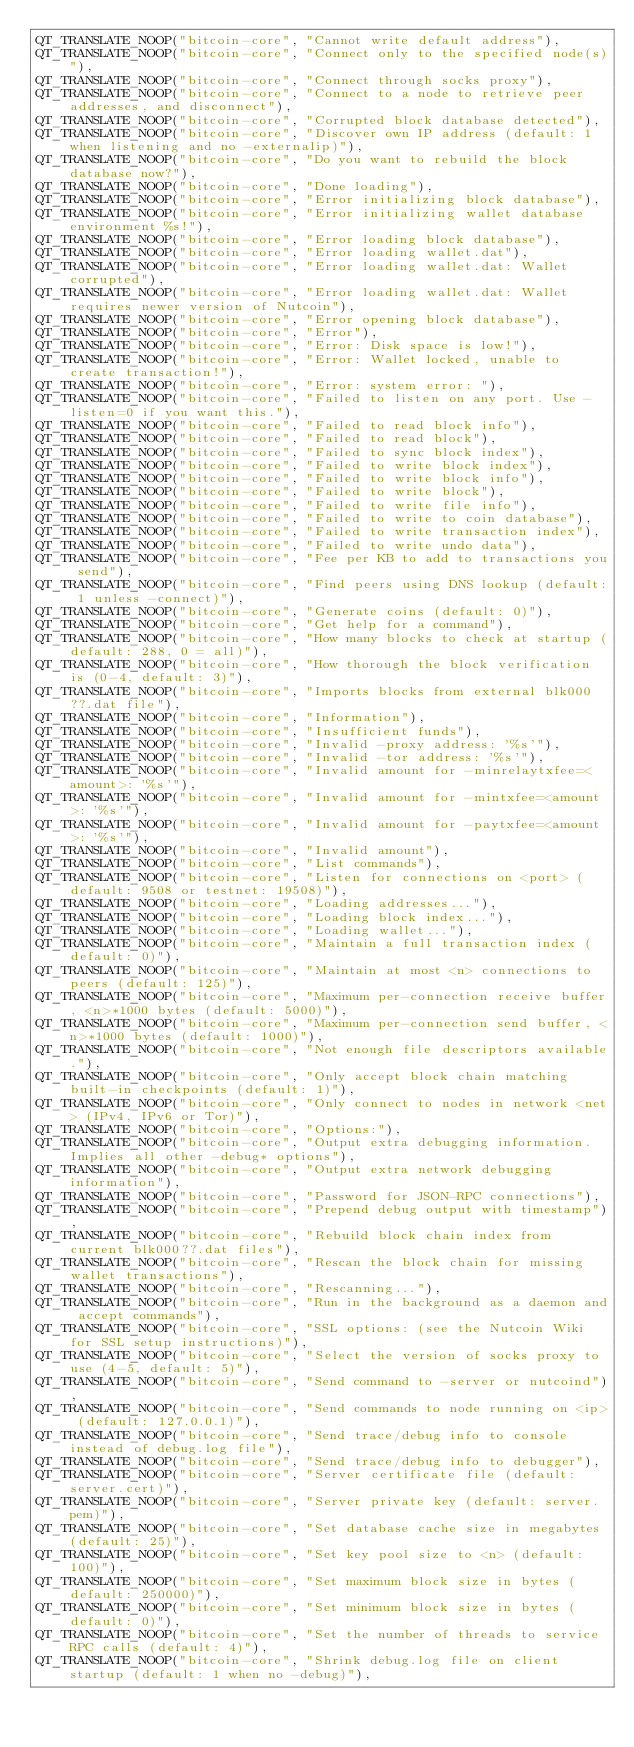Convert code to text. <code><loc_0><loc_0><loc_500><loc_500><_C++_>QT_TRANSLATE_NOOP("bitcoin-core", "Cannot write default address"),
QT_TRANSLATE_NOOP("bitcoin-core", "Connect only to the specified node(s)"),
QT_TRANSLATE_NOOP("bitcoin-core", "Connect through socks proxy"),
QT_TRANSLATE_NOOP("bitcoin-core", "Connect to a node to retrieve peer addresses, and disconnect"),
QT_TRANSLATE_NOOP("bitcoin-core", "Corrupted block database detected"),
QT_TRANSLATE_NOOP("bitcoin-core", "Discover own IP address (default: 1 when listening and no -externalip)"),
QT_TRANSLATE_NOOP("bitcoin-core", "Do you want to rebuild the block database now?"),
QT_TRANSLATE_NOOP("bitcoin-core", "Done loading"),
QT_TRANSLATE_NOOP("bitcoin-core", "Error initializing block database"),
QT_TRANSLATE_NOOP("bitcoin-core", "Error initializing wallet database environment %s!"),
QT_TRANSLATE_NOOP("bitcoin-core", "Error loading block database"),
QT_TRANSLATE_NOOP("bitcoin-core", "Error loading wallet.dat"),
QT_TRANSLATE_NOOP("bitcoin-core", "Error loading wallet.dat: Wallet corrupted"),
QT_TRANSLATE_NOOP("bitcoin-core", "Error loading wallet.dat: Wallet requires newer version of Nutcoin"),
QT_TRANSLATE_NOOP("bitcoin-core", "Error opening block database"),
QT_TRANSLATE_NOOP("bitcoin-core", "Error"),
QT_TRANSLATE_NOOP("bitcoin-core", "Error: Disk space is low!"),
QT_TRANSLATE_NOOP("bitcoin-core", "Error: Wallet locked, unable to create transaction!"),
QT_TRANSLATE_NOOP("bitcoin-core", "Error: system error: "),
QT_TRANSLATE_NOOP("bitcoin-core", "Failed to listen on any port. Use -listen=0 if you want this."),
QT_TRANSLATE_NOOP("bitcoin-core", "Failed to read block info"),
QT_TRANSLATE_NOOP("bitcoin-core", "Failed to read block"),
QT_TRANSLATE_NOOP("bitcoin-core", "Failed to sync block index"),
QT_TRANSLATE_NOOP("bitcoin-core", "Failed to write block index"),
QT_TRANSLATE_NOOP("bitcoin-core", "Failed to write block info"),
QT_TRANSLATE_NOOP("bitcoin-core", "Failed to write block"),
QT_TRANSLATE_NOOP("bitcoin-core", "Failed to write file info"),
QT_TRANSLATE_NOOP("bitcoin-core", "Failed to write to coin database"),
QT_TRANSLATE_NOOP("bitcoin-core", "Failed to write transaction index"),
QT_TRANSLATE_NOOP("bitcoin-core", "Failed to write undo data"),
QT_TRANSLATE_NOOP("bitcoin-core", "Fee per KB to add to transactions you send"),
QT_TRANSLATE_NOOP("bitcoin-core", "Find peers using DNS lookup (default: 1 unless -connect)"),
QT_TRANSLATE_NOOP("bitcoin-core", "Generate coins (default: 0)"),
QT_TRANSLATE_NOOP("bitcoin-core", "Get help for a command"),
QT_TRANSLATE_NOOP("bitcoin-core", "How many blocks to check at startup (default: 288, 0 = all)"),
QT_TRANSLATE_NOOP("bitcoin-core", "How thorough the block verification is (0-4, default: 3)"),
QT_TRANSLATE_NOOP("bitcoin-core", "Imports blocks from external blk000??.dat file"),
QT_TRANSLATE_NOOP("bitcoin-core", "Information"),
QT_TRANSLATE_NOOP("bitcoin-core", "Insufficient funds"),
QT_TRANSLATE_NOOP("bitcoin-core", "Invalid -proxy address: '%s'"),
QT_TRANSLATE_NOOP("bitcoin-core", "Invalid -tor address: '%s'"),
QT_TRANSLATE_NOOP("bitcoin-core", "Invalid amount for -minrelaytxfee=<amount>: '%s'"),
QT_TRANSLATE_NOOP("bitcoin-core", "Invalid amount for -mintxfee=<amount>: '%s'"),
QT_TRANSLATE_NOOP("bitcoin-core", "Invalid amount for -paytxfee=<amount>: '%s'"),
QT_TRANSLATE_NOOP("bitcoin-core", "Invalid amount"),
QT_TRANSLATE_NOOP("bitcoin-core", "List commands"),
QT_TRANSLATE_NOOP("bitcoin-core", "Listen for connections on <port> (default: 9508 or testnet: 19508)"),
QT_TRANSLATE_NOOP("bitcoin-core", "Loading addresses..."),
QT_TRANSLATE_NOOP("bitcoin-core", "Loading block index..."),
QT_TRANSLATE_NOOP("bitcoin-core", "Loading wallet..."),
QT_TRANSLATE_NOOP("bitcoin-core", "Maintain a full transaction index (default: 0)"),
QT_TRANSLATE_NOOP("bitcoin-core", "Maintain at most <n> connections to peers (default: 125)"),
QT_TRANSLATE_NOOP("bitcoin-core", "Maximum per-connection receive buffer, <n>*1000 bytes (default: 5000)"),
QT_TRANSLATE_NOOP("bitcoin-core", "Maximum per-connection send buffer, <n>*1000 bytes (default: 1000)"),
QT_TRANSLATE_NOOP("bitcoin-core", "Not enough file descriptors available."),
QT_TRANSLATE_NOOP("bitcoin-core", "Only accept block chain matching built-in checkpoints (default: 1)"),
QT_TRANSLATE_NOOP("bitcoin-core", "Only connect to nodes in network <net> (IPv4, IPv6 or Tor)"),
QT_TRANSLATE_NOOP("bitcoin-core", "Options:"),
QT_TRANSLATE_NOOP("bitcoin-core", "Output extra debugging information. Implies all other -debug* options"),
QT_TRANSLATE_NOOP("bitcoin-core", "Output extra network debugging information"),
QT_TRANSLATE_NOOP("bitcoin-core", "Password for JSON-RPC connections"),
QT_TRANSLATE_NOOP("bitcoin-core", "Prepend debug output with timestamp"),
QT_TRANSLATE_NOOP("bitcoin-core", "Rebuild block chain index from current blk000??.dat files"),
QT_TRANSLATE_NOOP("bitcoin-core", "Rescan the block chain for missing wallet transactions"),
QT_TRANSLATE_NOOP("bitcoin-core", "Rescanning..."),
QT_TRANSLATE_NOOP("bitcoin-core", "Run in the background as a daemon and accept commands"),
QT_TRANSLATE_NOOP("bitcoin-core", "SSL options: (see the Nutcoin Wiki for SSL setup instructions)"),
QT_TRANSLATE_NOOP("bitcoin-core", "Select the version of socks proxy to use (4-5, default: 5)"),
QT_TRANSLATE_NOOP("bitcoin-core", "Send command to -server or nutcoind"),
QT_TRANSLATE_NOOP("bitcoin-core", "Send commands to node running on <ip> (default: 127.0.0.1)"),
QT_TRANSLATE_NOOP("bitcoin-core", "Send trace/debug info to console instead of debug.log file"),
QT_TRANSLATE_NOOP("bitcoin-core", "Send trace/debug info to debugger"),
QT_TRANSLATE_NOOP("bitcoin-core", "Server certificate file (default: server.cert)"),
QT_TRANSLATE_NOOP("bitcoin-core", "Server private key (default: server.pem)"),
QT_TRANSLATE_NOOP("bitcoin-core", "Set database cache size in megabytes (default: 25)"),
QT_TRANSLATE_NOOP("bitcoin-core", "Set key pool size to <n> (default: 100)"),
QT_TRANSLATE_NOOP("bitcoin-core", "Set maximum block size in bytes (default: 250000)"),
QT_TRANSLATE_NOOP("bitcoin-core", "Set minimum block size in bytes (default: 0)"),
QT_TRANSLATE_NOOP("bitcoin-core", "Set the number of threads to service RPC calls (default: 4)"),
QT_TRANSLATE_NOOP("bitcoin-core", "Shrink debug.log file on client startup (default: 1 when no -debug)"),</code> 